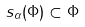Convert formula to latex. <formula><loc_0><loc_0><loc_500><loc_500>s _ { \alpha } ( \Phi ) \subset \Phi</formula> 